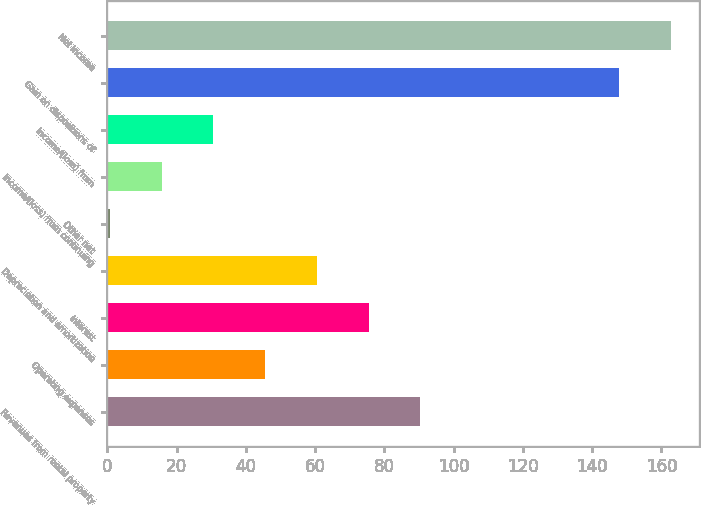Convert chart. <chart><loc_0><loc_0><loc_500><loc_500><bar_chart><fcel>Revenues from rental property<fcel>Operating expenses<fcel>Interest<fcel>Depreciation and amortization<fcel>Other net<fcel>Income/(loss) from continuing<fcel>Income/(loss) from<fcel>Gain on dispositions of<fcel>Net income<nl><fcel>90.34<fcel>45.52<fcel>75.4<fcel>60.46<fcel>0.7<fcel>15.64<fcel>30.58<fcel>147.8<fcel>162.74<nl></chart> 